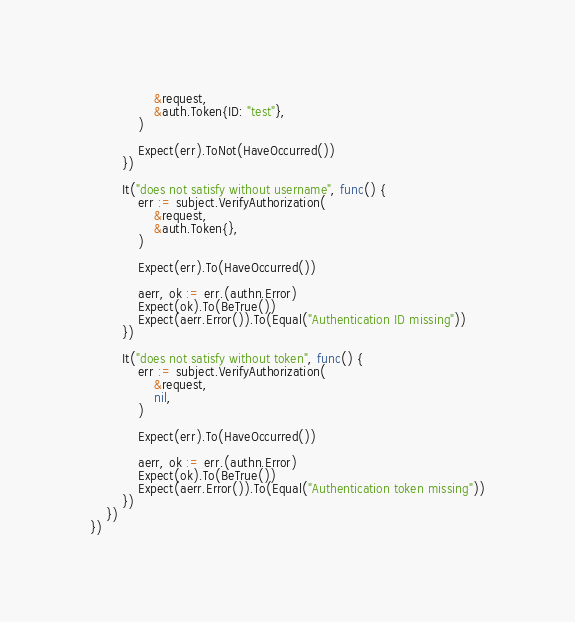Convert code to text. <code><loc_0><loc_0><loc_500><loc_500><_Go_>				&request,
				&auth.Token{ID: "test"},
			)

			Expect(err).ToNot(HaveOccurred())
		})

		It("does not satisfy without username", func() {
			err := subject.VerifyAuthorization(
				&request,
				&auth.Token{},
			)

			Expect(err).To(HaveOccurred())

			aerr, ok := err.(authn.Error)
			Expect(ok).To(BeTrue())
			Expect(aerr.Error()).To(Equal("Authentication ID missing"))
		})

		It("does not satisfy without token", func() {
			err := subject.VerifyAuthorization(
				&request,
				nil,
			)

			Expect(err).To(HaveOccurred())

			aerr, ok := err.(authn.Error)
			Expect(ok).To(BeTrue())
			Expect(aerr.Error()).To(Equal("Authentication token missing"))
		})
	})
})
</code> 